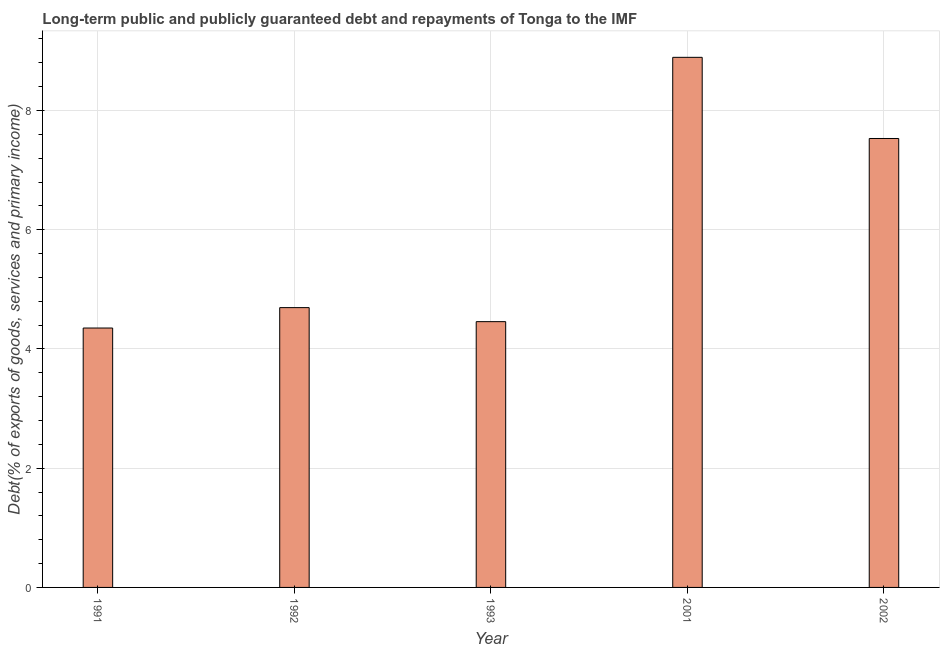Does the graph contain any zero values?
Make the answer very short. No. What is the title of the graph?
Your answer should be compact. Long-term public and publicly guaranteed debt and repayments of Tonga to the IMF. What is the label or title of the Y-axis?
Your answer should be compact. Debt(% of exports of goods, services and primary income). What is the debt service in 1993?
Your answer should be very brief. 4.46. Across all years, what is the maximum debt service?
Offer a very short reply. 8.89. Across all years, what is the minimum debt service?
Your response must be concise. 4.35. In which year was the debt service maximum?
Your answer should be very brief. 2001. What is the sum of the debt service?
Keep it short and to the point. 29.93. What is the difference between the debt service in 1991 and 1992?
Ensure brevity in your answer.  -0.34. What is the average debt service per year?
Make the answer very short. 5.99. What is the median debt service?
Provide a short and direct response. 4.69. What is the ratio of the debt service in 1992 to that in 1993?
Your answer should be compact. 1.05. What is the difference between the highest and the second highest debt service?
Your answer should be compact. 1.36. Is the sum of the debt service in 1991 and 2001 greater than the maximum debt service across all years?
Your answer should be compact. Yes. What is the difference between the highest and the lowest debt service?
Give a very brief answer. 4.54. In how many years, is the debt service greater than the average debt service taken over all years?
Your answer should be very brief. 2. How many bars are there?
Your answer should be compact. 5. Are all the bars in the graph horizontal?
Your answer should be very brief. No. How many years are there in the graph?
Keep it short and to the point. 5. What is the difference between two consecutive major ticks on the Y-axis?
Give a very brief answer. 2. Are the values on the major ticks of Y-axis written in scientific E-notation?
Provide a succinct answer. No. What is the Debt(% of exports of goods, services and primary income) in 1991?
Your answer should be compact. 4.35. What is the Debt(% of exports of goods, services and primary income) of 1992?
Provide a short and direct response. 4.69. What is the Debt(% of exports of goods, services and primary income) of 1993?
Give a very brief answer. 4.46. What is the Debt(% of exports of goods, services and primary income) of 2001?
Ensure brevity in your answer.  8.89. What is the Debt(% of exports of goods, services and primary income) of 2002?
Your answer should be very brief. 7.53. What is the difference between the Debt(% of exports of goods, services and primary income) in 1991 and 1992?
Make the answer very short. -0.34. What is the difference between the Debt(% of exports of goods, services and primary income) in 1991 and 1993?
Keep it short and to the point. -0.11. What is the difference between the Debt(% of exports of goods, services and primary income) in 1991 and 2001?
Your response must be concise. -4.54. What is the difference between the Debt(% of exports of goods, services and primary income) in 1991 and 2002?
Make the answer very short. -3.18. What is the difference between the Debt(% of exports of goods, services and primary income) in 1992 and 1993?
Your response must be concise. 0.24. What is the difference between the Debt(% of exports of goods, services and primary income) in 1992 and 2001?
Keep it short and to the point. -4.2. What is the difference between the Debt(% of exports of goods, services and primary income) in 1992 and 2002?
Provide a succinct answer. -2.84. What is the difference between the Debt(% of exports of goods, services and primary income) in 1993 and 2001?
Your answer should be very brief. -4.43. What is the difference between the Debt(% of exports of goods, services and primary income) in 1993 and 2002?
Provide a succinct answer. -3.07. What is the difference between the Debt(% of exports of goods, services and primary income) in 2001 and 2002?
Keep it short and to the point. 1.36. What is the ratio of the Debt(% of exports of goods, services and primary income) in 1991 to that in 1992?
Ensure brevity in your answer.  0.93. What is the ratio of the Debt(% of exports of goods, services and primary income) in 1991 to that in 2001?
Provide a short and direct response. 0.49. What is the ratio of the Debt(% of exports of goods, services and primary income) in 1991 to that in 2002?
Provide a succinct answer. 0.58. What is the ratio of the Debt(% of exports of goods, services and primary income) in 1992 to that in 1993?
Give a very brief answer. 1.05. What is the ratio of the Debt(% of exports of goods, services and primary income) in 1992 to that in 2001?
Your response must be concise. 0.53. What is the ratio of the Debt(% of exports of goods, services and primary income) in 1992 to that in 2002?
Keep it short and to the point. 0.62. What is the ratio of the Debt(% of exports of goods, services and primary income) in 1993 to that in 2001?
Keep it short and to the point. 0.5. What is the ratio of the Debt(% of exports of goods, services and primary income) in 1993 to that in 2002?
Keep it short and to the point. 0.59. What is the ratio of the Debt(% of exports of goods, services and primary income) in 2001 to that in 2002?
Offer a very short reply. 1.18. 